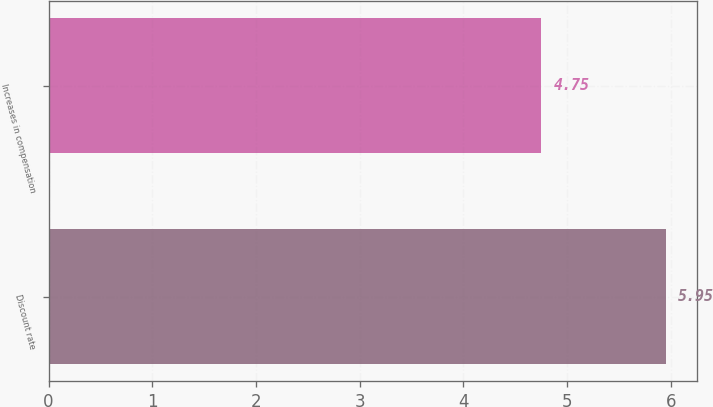<chart> <loc_0><loc_0><loc_500><loc_500><bar_chart><fcel>Discount rate<fcel>Increases in compensation<nl><fcel>5.95<fcel>4.75<nl></chart> 